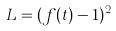<formula> <loc_0><loc_0><loc_500><loc_500>L = ( f ( t ) - 1 ) ^ { 2 }</formula> 